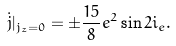<formula> <loc_0><loc_0><loc_500><loc_500>\dot { j } | _ { j _ { z } = 0 } = \pm \frac { 1 5 } { 8 } e ^ { 2 } \sin 2 i _ { e } .</formula> 